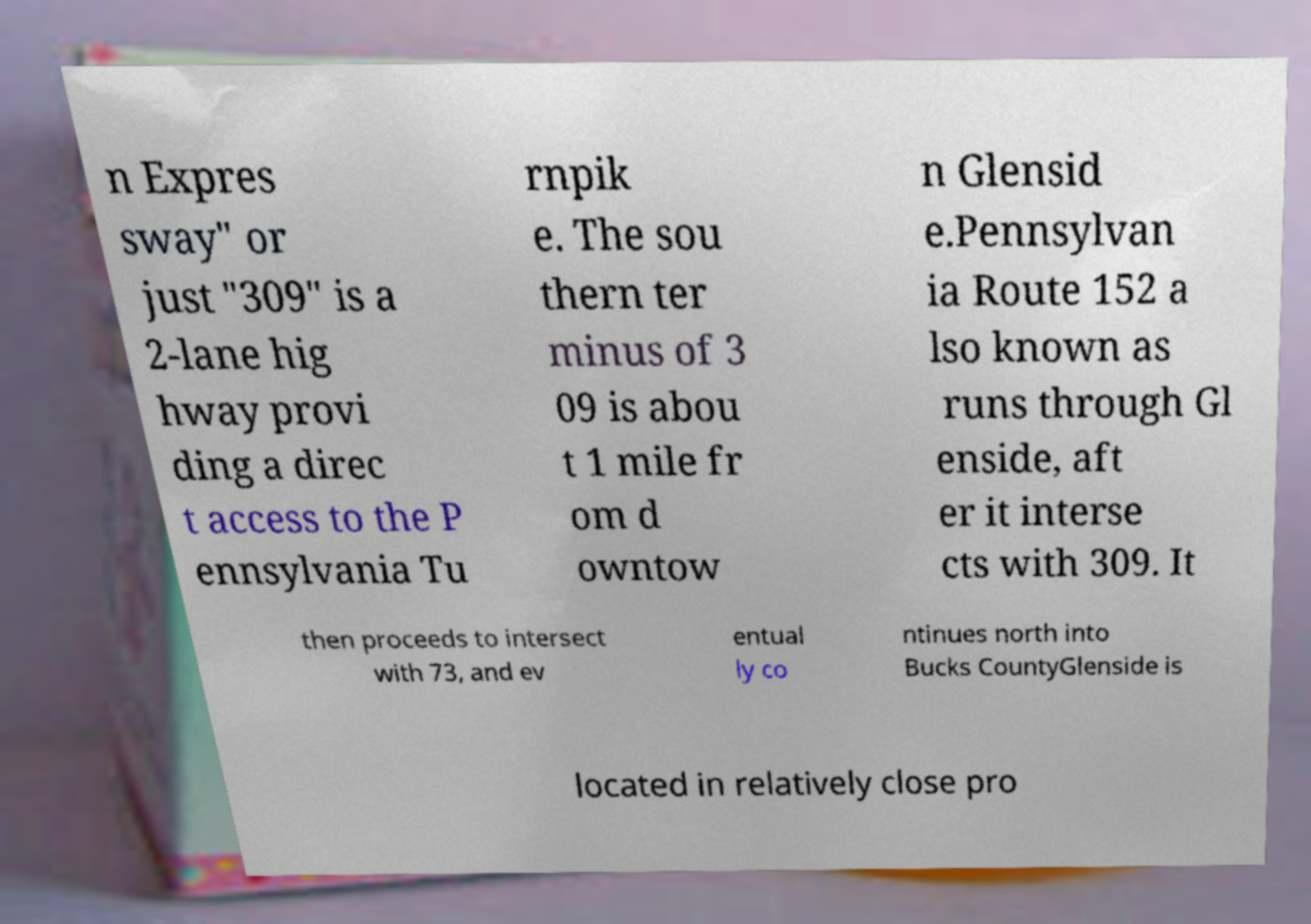Please read and relay the text visible in this image. What does it say? n Expres sway" or just "309" is a 2-lane hig hway provi ding a direc t access to the P ennsylvania Tu rnpik e. The sou thern ter minus of 3 09 is abou t 1 mile fr om d owntow n Glensid e.Pennsylvan ia Route 152 a lso known as runs through Gl enside, aft er it interse cts with 309. It then proceeds to intersect with 73, and ev entual ly co ntinues north into Bucks CountyGlenside is located in relatively close pro 